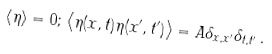Convert formula to latex. <formula><loc_0><loc_0><loc_500><loc_500>\left \langle \eta \right \rangle = 0 ; \, \left \langle \eta ( x , t ) \eta ( x ^ { \prime } , t ^ { \prime } ) \right \rangle = A \delta _ { x , x ^ { \prime } } \delta _ { t , t ^ { \prime } } \, .</formula> 